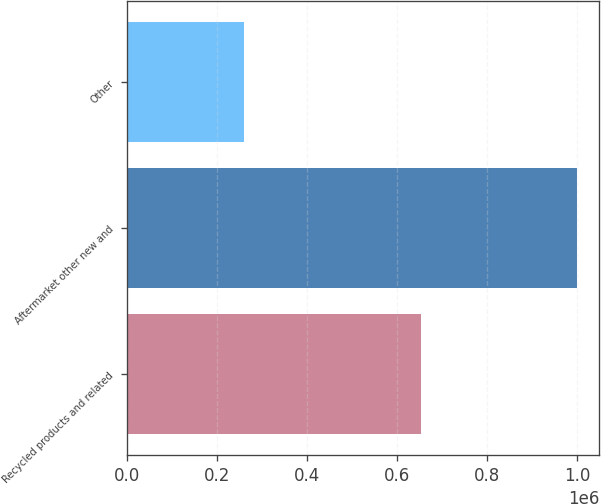Convert chart to OTSL. <chart><loc_0><loc_0><loc_500><loc_500><bar_chart><fcel>Recycled products and related<fcel>Aftermarket other new and<fcel>Other<nl><fcel>651803<fcel>998541<fcel>258188<nl></chart> 